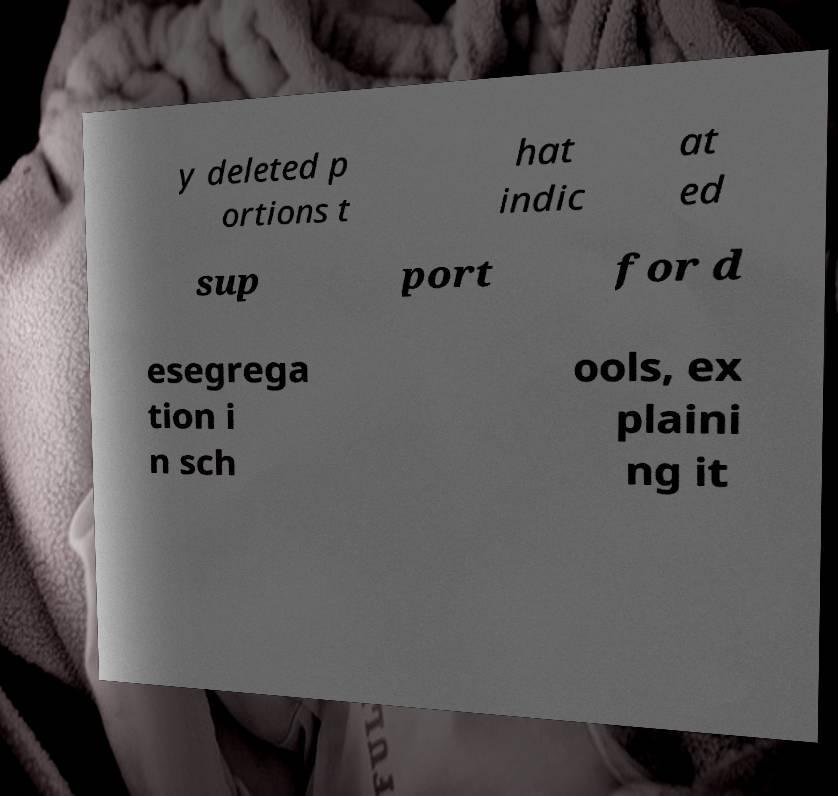Could you assist in decoding the text presented in this image and type it out clearly? y deleted p ortions t hat indic at ed sup port for d esegrega tion i n sch ools, ex plaini ng it 